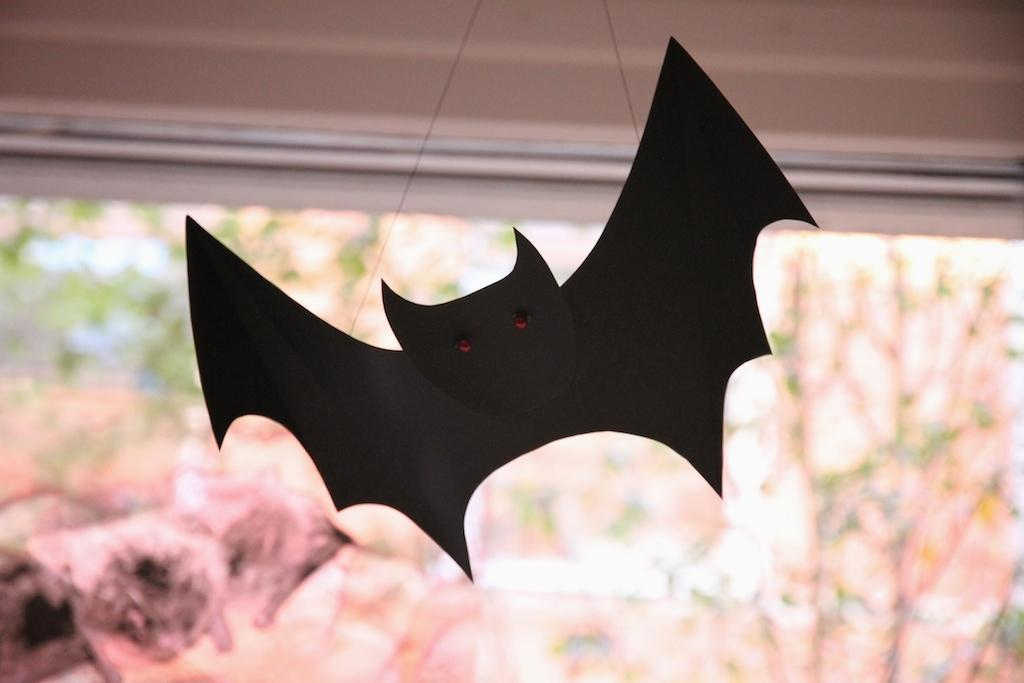What is the main subject in the foreground of the image? There is a paper bat in the foreground of the image. Where is the paper bat located? The paper bat is hanged on a rooftop. What else can be seen in the foreground of the image? There are plants visible in the foreground of the image. What time of day does the image appear to be taken? The image appears to be taken during the day. What is visible at the top of the image? There is a rooftop visible at the top of the image. What type of crib is visible in the image? There is no crib present in the image. What is the paper bat using to hit the ball in the image? The paper bat is not hitting a ball in the image; it is simply hanging on a rooftop. 